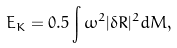<formula> <loc_0><loc_0><loc_500><loc_500>E _ { K } = 0 . 5 \int \omega ^ { 2 } | \delta R | ^ { 2 } d M ,</formula> 